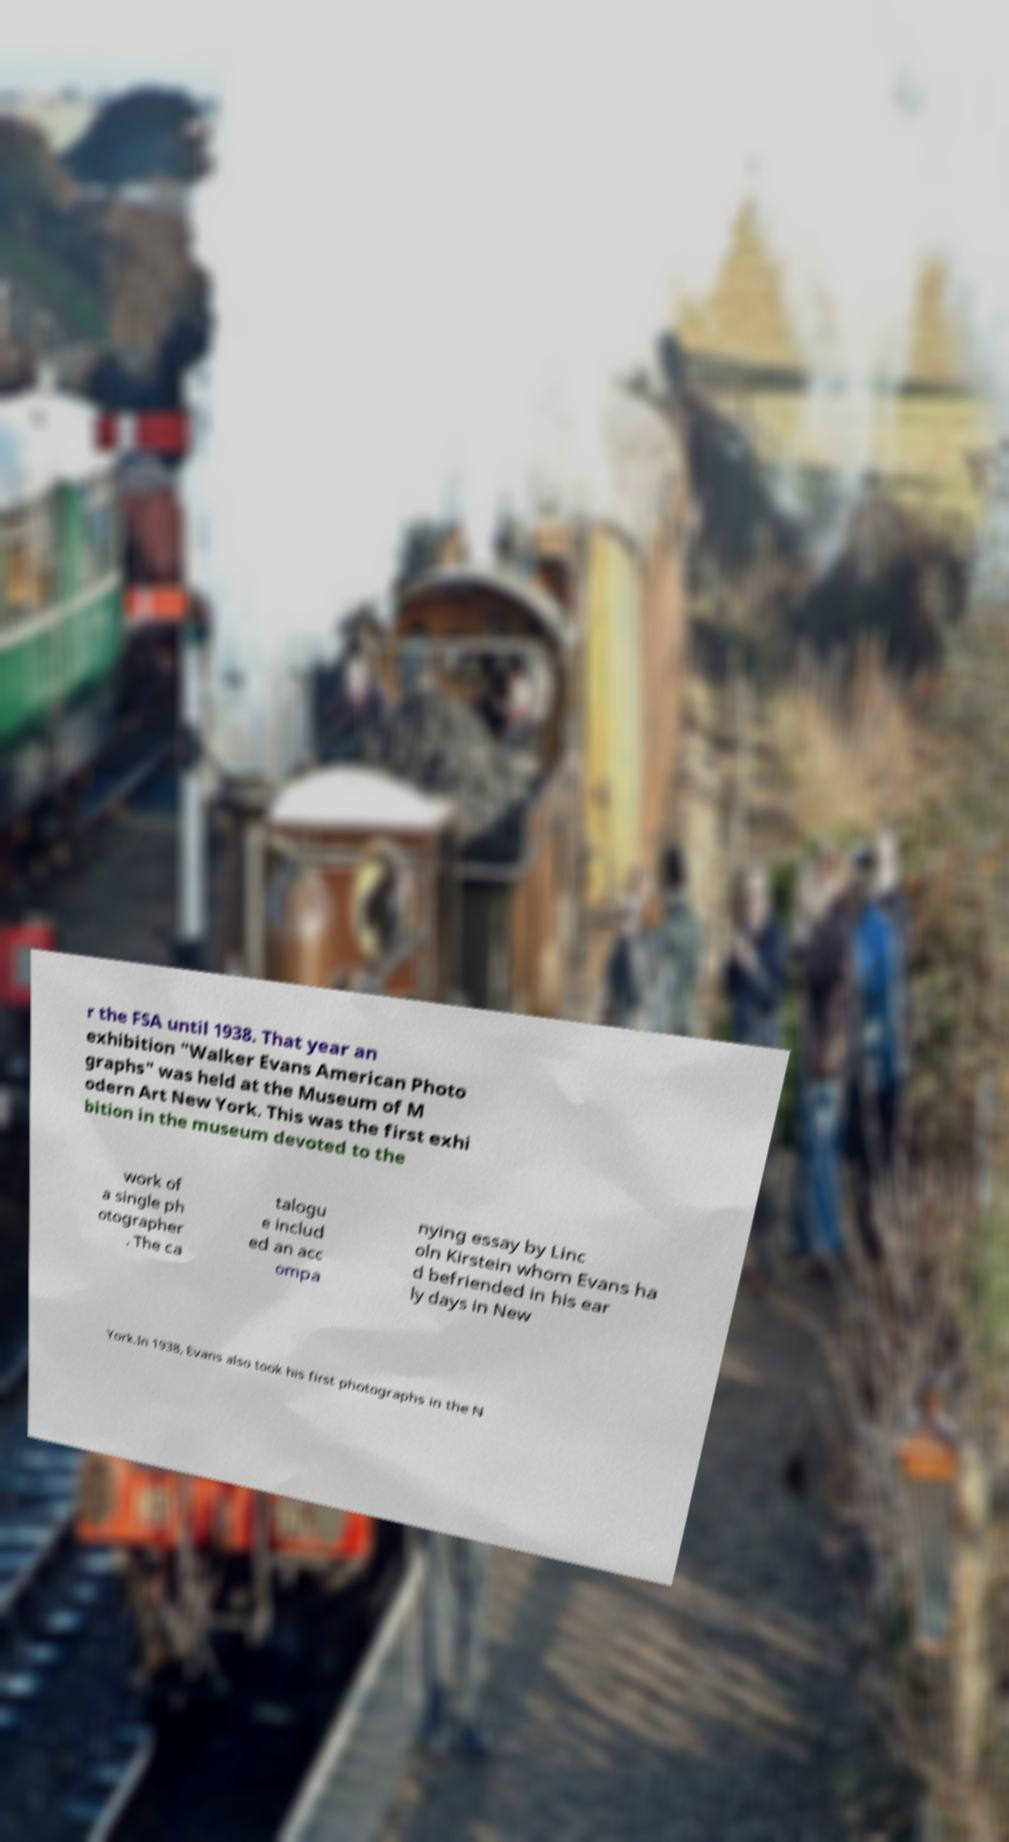What messages or text are displayed in this image? I need them in a readable, typed format. r the FSA until 1938. That year an exhibition "Walker Evans American Photo graphs" was held at the Museum of M odern Art New York. This was the first exhi bition in the museum devoted to the work of a single ph otographer . The ca talogu e includ ed an acc ompa nying essay by Linc oln Kirstein whom Evans ha d befriended in his ear ly days in New York.In 1938, Evans also took his first photographs in the N 